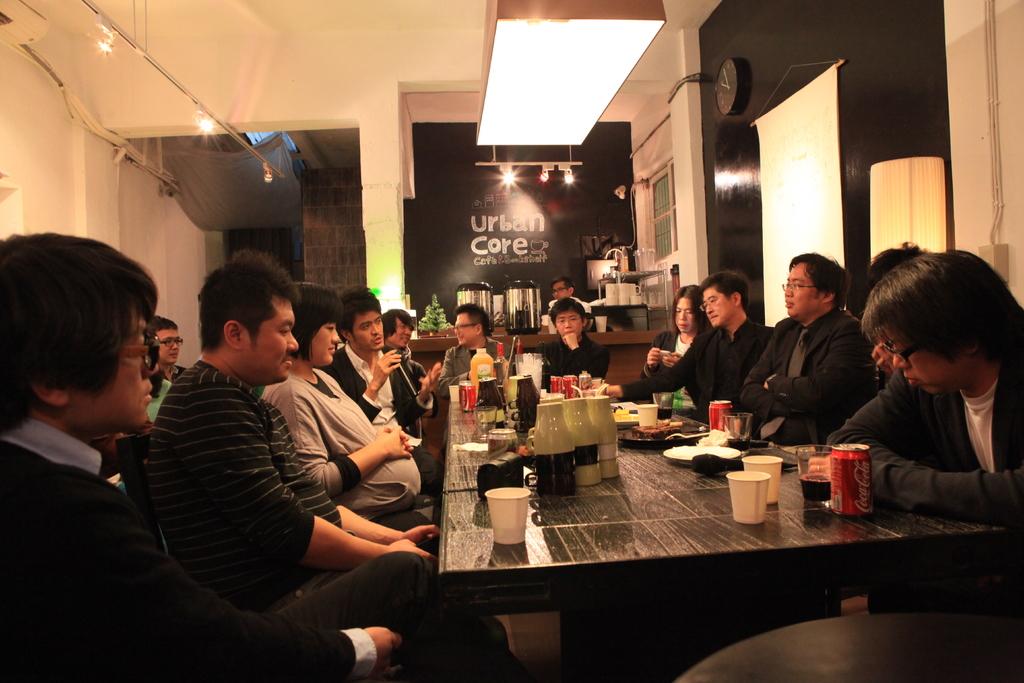What kind of soda are they drinking?
Your answer should be very brief. Coca cola. 